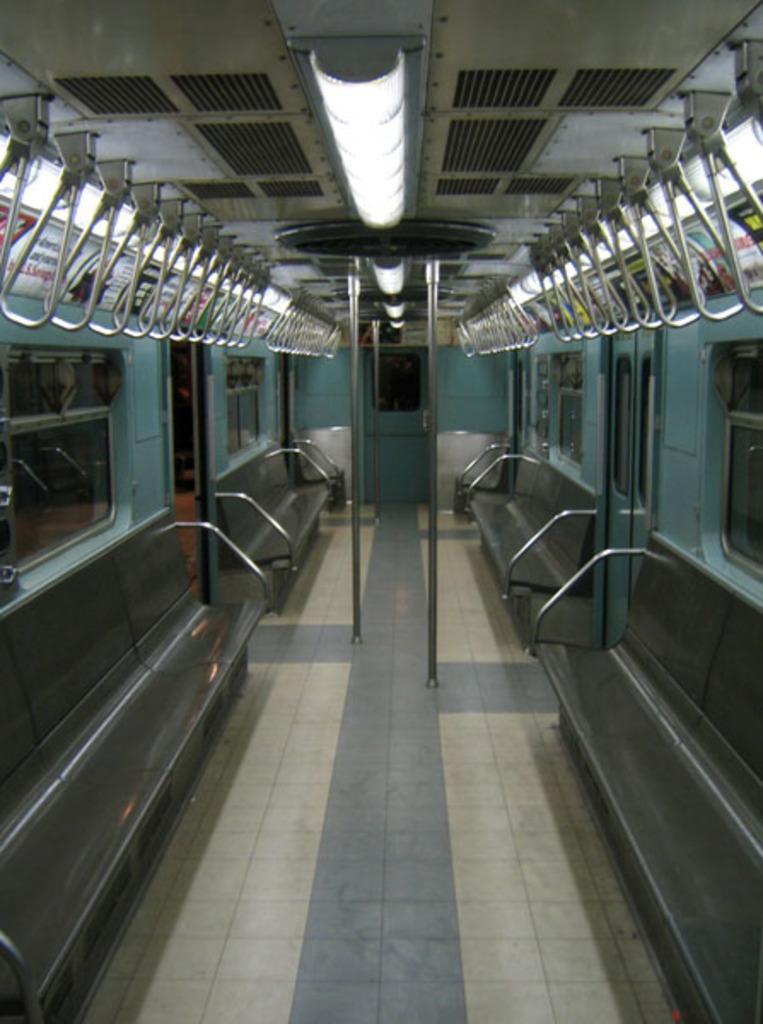Describe this image in one or two sentences. In the picture I can see benches, lights, poles, windows and some other objects. This is an inside view of a train. 